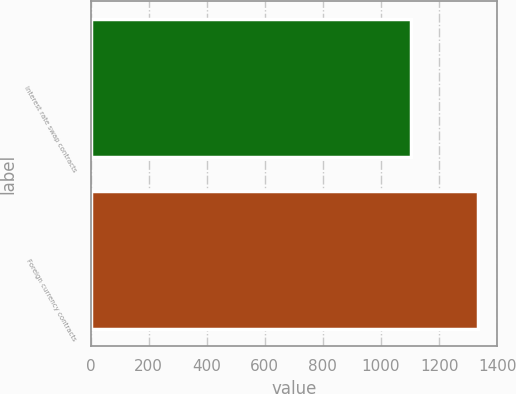Convert chart. <chart><loc_0><loc_0><loc_500><loc_500><bar_chart><fcel>Interest rate swap contracts<fcel>Foreign currency contracts<nl><fcel>1103.8<fcel>1334.1<nl></chart> 